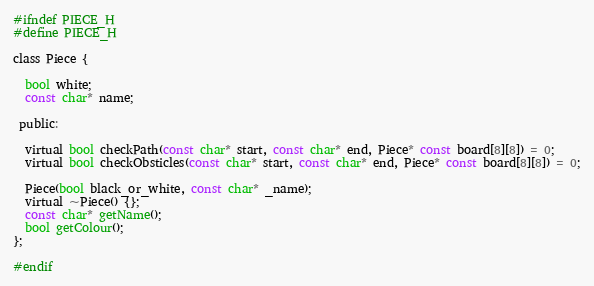<code> <loc_0><loc_0><loc_500><loc_500><_C_>#ifndef PIECE_H
#define PIECE_H

class Piece {

  bool white;
  const char* name;
  
 public:

  virtual bool checkPath(const char* start, const char* end, Piece* const board[8][8]) = 0;
  virtual bool checkObsticles(const char* start, const char* end, Piece* const board[8][8]) = 0;

  Piece(bool black_or_white, const char* _name);
  virtual ~Piece() {};
  const char* getName();
  bool getColour();
};

#endif
</code> 